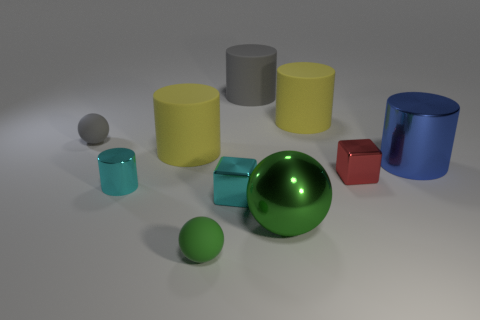Subtract all small gray matte spheres. How many spheres are left? 2 Subtract all red blocks. How many blocks are left? 1 Subtract 2 spheres. How many spheres are left? 1 Subtract all purple blocks. How many blue cylinders are left? 1 Subtract 2 green balls. How many objects are left? 8 Subtract all blocks. How many objects are left? 8 Subtract all green cubes. Subtract all brown spheres. How many cubes are left? 2 Subtract all big rubber cylinders. Subtract all gray spheres. How many objects are left? 6 Add 6 blue shiny things. How many blue shiny things are left? 7 Add 9 tiny blue matte cylinders. How many tiny blue matte cylinders exist? 9 